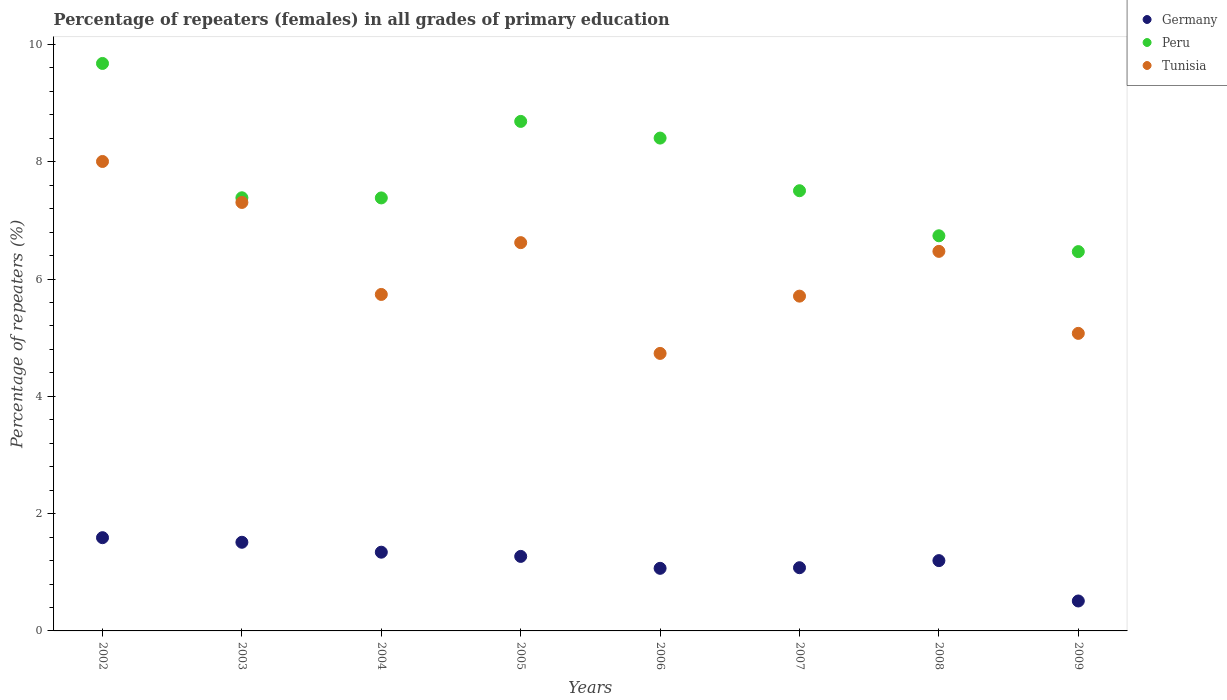What is the percentage of repeaters (females) in Germany in 2005?
Ensure brevity in your answer.  1.27. Across all years, what is the maximum percentage of repeaters (females) in Peru?
Make the answer very short. 9.68. Across all years, what is the minimum percentage of repeaters (females) in Peru?
Your answer should be very brief. 6.47. In which year was the percentage of repeaters (females) in Tunisia minimum?
Your answer should be very brief. 2006. What is the total percentage of repeaters (females) in Tunisia in the graph?
Offer a terse response. 49.65. What is the difference between the percentage of repeaters (females) in Germany in 2003 and that in 2008?
Keep it short and to the point. 0.31. What is the difference between the percentage of repeaters (females) in Tunisia in 2006 and the percentage of repeaters (females) in Peru in 2009?
Offer a very short reply. -1.74. What is the average percentage of repeaters (females) in Germany per year?
Provide a short and direct response. 1.2. In the year 2003, what is the difference between the percentage of repeaters (females) in Peru and percentage of repeaters (females) in Germany?
Your answer should be compact. 5.87. In how many years, is the percentage of repeaters (females) in Tunisia greater than 6.4 %?
Keep it short and to the point. 4. What is the ratio of the percentage of repeaters (females) in Tunisia in 2003 to that in 2008?
Give a very brief answer. 1.13. What is the difference between the highest and the second highest percentage of repeaters (females) in Germany?
Ensure brevity in your answer.  0.08. What is the difference between the highest and the lowest percentage of repeaters (females) in Peru?
Your response must be concise. 3.21. Is the sum of the percentage of repeaters (females) in Peru in 2002 and 2004 greater than the maximum percentage of repeaters (females) in Tunisia across all years?
Your response must be concise. Yes. Does the percentage of repeaters (females) in Peru monotonically increase over the years?
Your response must be concise. No. Is the percentage of repeaters (females) in Tunisia strictly greater than the percentage of repeaters (females) in Peru over the years?
Provide a short and direct response. No. Is the percentage of repeaters (females) in Tunisia strictly less than the percentage of repeaters (females) in Peru over the years?
Provide a short and direct response. Yes. How many years are there in the graph?
Give a very brief answer. 8. What is the difference between two consecutive major ticks on the Y-axis?
Give a very brief answer. 2. Are the values on the major ticks of Y-axis written in scientific E-notation?
Provide a succinct answer. No. Does the graph contain any zero values?
Your answer should be very brief. No. Does the graph contain grids?
Your answer should be very brief. No. Where does the legend appear in the graph?
Your response must be concise. Top right. How are the legend labels stacked?
Your response must be concise. Vertical. What is the title of the graph?
Provide a short and direct response. Percentage of repeaters (females) in all grades of primary education. Does "Andorra" appear as one of the legend labels in the graph?
Provide a succinct answer. No. What is the label or title of the Y-axis?
Provide a short and direct response. Percentage of repeaters (%). What is the Percentage of repeaters (%) in Germany in 2002?
Provide a short and direct response. 1.59. What is the Percentage of repeaters (%) of Peru in 2002?
Provide a short and direct response. 9.68. What is the Percentage of repeaters (%) in Tunisia in 2002?
Provide a succinct answer. 8. What is the Percentage of repeaters (%) in Germany in 2003?
Your response must be concise. 1.51. What is the Percentage of repeaters (%) in Peru in 2003?
Your response must be concise. 7.39. What is the Percentage of repeaters (%) of Tunisia in 2003?
Provide a short and direct response. 7.31. What is the Percentage of repeaters (%) in Germany in 2004?
Ensure brevity in your answer.  1.34. What is the Percentage of repeaters (%) of Peru in 2004?
Provide a short and direct response. 7.38. What is the Percentage of repeaters (%) of Tunisia in 2004?
Keep it short and to the point. 5.74. What is the Percentage of repeaters (%) of Germany in 2005?
Give a very brief answer. 1.27. What is the Percentage of repeaters (%) in Peru in 2005?
Provide a short and direct response. 8.69. What is the Percentage of repeaters (%) in Tunisia in 2005?
Your response must be concise. 6.62. What is the Percentage of repeaters (%) of Germany in 2006?
Provide a short and direct response. 1.07. What is the Percentage of repeaters (%) of Peru in 2006?
Offer a very short reply. 8.4. What is the Percentage of repeaters (%) in Tunisia in 2006?
Offer a terse response. 4.73. What is the Percentage of repeaters (%) of Germany in 2007?
Keep it short and to the point. 1.08. What is the Percentage of repeaters (%) in Peru in 2007?
Offer a very short reply. 7.51. What is the Percentage of repeaters (%) in Tunisia in 2007?
Keep it short and to the point. 5.71. What is the Percentage of repeaters (%) in Germany in 2008?
Offer a very short reply. 1.2. What is the Percentage of repeaters (%) of Peru in 2008?
Your answer should be very brief. 6.74. What is the Percentage of repeaters (%) in Tunisia in 2008?
Your answer should be compact. 6.47. What is the Percentage of repeaters (%) of Germany in 2009?
Provide a succinct answer. 0.51. What is the Percentage of repeaters (%) in Peru in 2009?
Keep it short and to the point. 6.47. What is the Percentage of repeaters (%) in Tunisia in 2009?
Make the answer very short. 5.07. Across all years, what is the maximum Percentage of repeaters (%) of Germany?
Your answer should be very brief. 1.59. Across all years, what is the maximum Percentage of repeaters (%) in Peru?
Ensure brevity in your answer.  9.68. Across all years, what is the maximum Percentage of repeaters (%) of Tunisia?
Provide a short and direct response. 8. Across all years, what is the minimum Percentage of repeaters (%) in Germany?
Your response must be concise. 0.51. Across all years, what is the minimum Percentage of repeaters (%) in Peru?
Keep it short and to the point. 6.47. Across all years, what is the minimum Percentage of repeaters (%) in Tunisia?
Offer a very short reply. 4.73. What is the total Percentage of repeaters (%) in Germany in the graph?
Offer a very short reply. 9.57. What is the total Percentage of repeaters (%) in Peru in the graph?
Give a very brief answer. 62.25. What is the total Percentage of repeaters (%) of Tunisia in the graph?
Offer a very short reply. 49.65. What is the difference between the Percentage of repeaters (%) of Germany in 2002 and that in 2003?
Offer a very short reply. 0.08. What is the difference between the Percentage of repeaters (%) in Peru in 2002 and that in 2003?
Your answer should be compact. 2.29. What is the difference between the Percentage of repeaters (%) of Tunisia in 2002 and that in 2003?
Your answer should be compact. 0.7. What is the difference between the Percentage of repeaters (%) in Germany in 2002 and that in 2004?
Offer a very short reply. 0.25. What is the difference between the Percentage of repeaters (%) of Peru in 2002 and that in 2004?
Give a very brief answer. 2.29. What is the difference between the Percentage of repeaters (%) in Tunisia in 2002 and that in 2004?
Provide a short and direct response. 2.27. What is the difference between the Percentage of repeaters (%) of Germany in 2002 and that in 2005?
Provide a short and direct response. 0.32. What is the difference between the Percentage of repeaters (%) in Tunisia in 2002 and that in 2005?
Provide a succinct answer. 1.38. What is the difference between the Percentage of repeaters (%) in Germany in 2002 and that in 2006?
Keep it short and to the point. 0.52. What is the difference between the Percentage of repeaters (%) in Peru in 2002 and that in 2006?
Offer a very short reply. 1.27. What is the difference between the Percentage of repeaters (%) in Tunisia in 2002 and that in 2006?
Offer a terse response. 3.27. What is the difference between the Percentage of repeaters (%) in Germany in 2002 and that in 2007?
Ensure brevity in your answer.  0.51. What is the difference between the Percentage of repeaters (%) in Peru in 2002 and that in 2007?
Offer a terse response. 2.17. What is the difference between the Percentage of repeaters (%) of Tunisia in 2002 and that in 2007?
Provide a succinct answer. 2.3. What is the difference between the Percentage of repeaters (%) in Germany in 2002 and that in 2008?
Offer a terse response. 0.39. What is the difference between the Percentage of repeaters (%) of Peru in 2002 and that in 2008?
Give a very brief answer. 2.94. What is the difference between the Percentage of repeaters (%) of Tunisia in 2002 and that in 2008?
Your answer should be compact. 1.53. What is the difference between the Percentage of repeaters (%) of Germany in 2002 and that in 2009?
Your response must be concise. 1.08. What is the difference between the Percentage of repeaters (%) of Peru in 2002 and that in 2009?
Provide a succinct answer. 3.21. What is the difference between the Percentage of repeaters (%) of Tunisia in 2002 and that in 2009?
Your answer should be very brief. 2.93. What is the difference between the Percentage of repeaters (%) of Germany in 2003 and that in 2004?
Provide a succinct answer. 0.17. What is the difference between the Percentage of repeaters (%) of Peru in 2003 and that in 2004?
Your answer should be very brief. 0. What is the difference between the Percentage of repeaters (%) in Tunisia in 2003 and that in 2004?
Your answer should be very brief. 1.57. What is the difference between the Percentage of repeaters (%) of Germany in 2003 and that in 2005?
Provide a succinct answer. 0.24. What is the difference between the Percentage of repeaters (%) in Peru in 2003 and that in 2005?
Your response must be concise. -1.3. What is the difference between the Percentage of repeaters (%) of Tunisia in 2003 and that in 2005?
Your answer should be compact. 0.69. What is the difference between the Percentage of repeaters (%) in Germany in 2003 and that in 2006?
Make the answer very short. 0.44. What is the difference between the Percentage of repeaters (%) of Peru in 2003 and that in 2006?
Your answer should be compact. -1.02. What is the difference between the Percentage of repeaters (%) in Tunisia in 2003 and that in 2006?
Ensure brevity in your answer.  2.57. What is the difference between the Percentage of repeaters (%) in Germany in 2003 and that in 2007?
Offer a very short reply. 0.43. What is the difference between the Percentage of repeaters (%) in Peru in 2003 and that in 2007?
Provide a short and direct response. -0.12. What is the difference between the Percentage of repeaters (%) of Tunisia in 2003 and that in 2007?
Offer a very short reply. 1.6. What is the difference between the Percentage of repeaters (%) in Germany in 2003 and that in 2008?
Your response must be concise. 0.31. What is the difference between the Percentage of repeaters (%) of Peru in 2003 and that in 2008?
Provide a short and direct response. 0.65. What is the difference between the Percentage of repeaters (%) of Tunisia in 2003 and that in 2008?
Ensure brevity in your answer.  0.83. What is the difference between the Percentage of repeaters (%) of Peru in 2003 and that in 2009?
Provide a short and direct response. 0.92. What is the difference between the Percentage of repeaters (%) of Tunisia in 2003 and that in 2009?
Your response must be concise. 2.23. What is the difference between the Percentage of repeaters (%) of Germany in 2004 and that in 2005?
Your answer should be compact. 0.07. What is the difference between the Percentage of repeaters (%) of Peru in 2004 and that in 2005?
Your response must be concise. -1.3. What is the difference between the Percentage of repeaters (%) of Tunisia in 2004 and that in 2005?
Your answer should be very brief. -0.88. What is the difference between the Percentage of repeaters (%) in Germany in 2004 and that in 2006?
Your answer should be compact. 0.28. What is the difference between the Percentage of repeaters (%) of Peru in 2004 and that in 2006?
Provide a short and direct response. -1.02. What is the difference between the Percentage of repeaters (%) in Germany in 2004 and that in 2007?
Ensure brevity in your answer.  0.26. What is the difference between the Percentage of repeaters (%) in Peru in 2004 and that in 2007?
Offer a very short reply. -0.12. What is the difference between the Percentage of repeaters (%) in Tunisia in 2004 and that in 2007?
Offer a very short reply. 0.03. What is the difference between the Percentage of repeaters (%) of Germany in 2004 and that in 2008?
Your response must be concise. 0.14. What is the difference between the Percentage of repeaters (%) in Peru in 2004 and that in 2008?
Offer a terse response. 0.65. What is the difference between the Percentage of repeaters (%) in Tunisia in 2004 and that in 2008?
Offer a very short reply. -0.73. What is the difference between the Percentage of repeaters (%) in Germany in 2004 and that in 2009?
Make the answer very short. 0.83. What is the difference between the Percentage of repeaters (%) in Peru in 2004 and that in 2009?
Provide a short and direct response. 0.92. What is the difference between the Percentage of repeaters (%) of Tunisia in 2004 and that in 2009?
Keep it short and to the point. 0.66. What is the difference between the Percentage of repeaters (%) of Germany in 2005 and that in 2006?
Provide a succinct answer. 0.2. What is the difference between the Percentage of repeaters (%) of Peru in 2005 and that in 2006?
Your answer should be very brief. 0.28. What is the difference between the Percentage of repeaters (%) of Tunisia in 2005 and that in 2006?
Provide a short and direct response. 1.89. What is the difference between the Percentage of repeaters (%) of Germany in 2005 and that in 2007?
Make the answer very short. 0.19. What is the difference between the Percentage of repeaters (%) of Peru in 2005 and that in 2007?
Provide a succinct answer. 1.18. What is the difference between the Percentage of repeaters (%) in Tunisia in 2005 and that in 2007?
Offer a very short reply. 0.91. What is the difference between the Percentage of repeaters (%) in Germany in 2005 and that in 2008?
Ensure brevity in your answer.  0.07. What is the difference between the Percentage of repeaters (%) in Peru in 2005 and that in 2008?
Offer a very short reply. 1.95. What is the difference between the Percentage of repeaters (%) of Tunisia in 2005 and that in 2008?
Your answer should be compact. 0.15. What is the difference between the Percentage of repeaters (%) of Germany in 2005 and that in 2009?
Your response must be concise. 0.76. What is the difference between the Percentage of repeaters (%) of Peru in 2005 and that in 2009?
Provide a succinct answer. 2.22. What is the difference between the Percentage of repeaters (%) in Tunisia in 2005 and that in 2009?
Make the answer very short. 1.55. What is the difference between the Percentage of repeaters (%) of Germany in 2006 and that in 2007?
Make the answer very short. -0.01. What is the difference between the Percentage of repeaters (%) of Peru in 2006 and that in 2007?
Provide a succinct answer. 0.9. What is the difference between the Percentage of repeaters (%) of Tunisia in 2006 and that in 2007?
Offer a very short reply. -0.98. What is the difference between the Percentage of repeaters (%) of Germany in 2006 and that in 2008?
Keep it short and to the point. -0.13. What is the difference between the Percentage of repeaters (%) in Peru in 2006 and that in 2008?
Give a very brief answer. 1.67. What is the difference between the Percentage of repeaters (%) in Tunisia in 2006 and that in 2008?
Make the answer very short. -1.74. What is the difference between the Percentage of repeaters (%) in Germany in 2006 and that in 2009?
Your answer should be very brief. 0.56. What is the difference between the Percentage of repeaters (%) of Peru in 2006 and that in 2009?
Provide a short and direct response. 1.94. What is the difference between the Percentage of repeaters (%) in Tunisia in 2006 and that in 2009?
Offer a very short reply. -0.34. What is the difference between the Percentage of repeaters (%) of Germany in 2007 and that in 2008?
Offer a terse response. -0.12. What is the difference between the Percentage of repeaters (%) in Peru in 2007 and that in 2008?
Give a very brief answer. 0.77. What is the difference between the Percentage of repeaters (%) in Tunisia in 2007 and that in 2008?
Your response must be concise. -0.76. What is the difference between the Percentage of repeaters (%) in Germany in 2007 and that in 2009?
Your answer should be compact. 0.57. What is the difference between the Percentage of repeaters (%) in Peru in 2007 and that in 2009?
Offer a very short reply. 1.04. What is the difference between the Percentage of repeaters (%) in Tunisia in 2007 and that in 2009?
Provide a succinct answer. 0.63. What is the difference between the Percentage of repeaters (%) in Germany in 2008 and that in 2009?
Provide a succinct answer. 0.69. What is the difference between the Percentage of repeaters (%) in Peru in 2008 and that in 2009?
Offer a terse response. 0.27. What is the difference between the Percentage of repeaters (%) of Tunisia in 2008 and that in 2009?
Give a very brief answer. 1.4. What is the difference between the Percentage of repeaters (%) in Germany in 2002 and the Percentage of repeaters (%) in Peru in 2003?
Provide a succinct answer. -5.8. What is the difference between the Percentage of repeaters (%) in Germany in 2002 and the Percentage of repeaters (%) in Tunisia in 2003?
Offer a terse response. -5.72. What is the difference between the Percentage of repeaters (%) in Peru in 2002 and the Percentage of repeaters (%) in Tunisia in 2003?
Provide a short and direct response. 2.37. What is the difference between the Percentage of repeaters (%) of Germany in 2002 and the Percentage of repeaters (%) of Peru in 2004?
Give a very brief answer. -5.79. What is the difference between the Percentage of repeaters (%) in Germany in 2002 and the Percentage of repeaters (%) in Tunisia in 2004?
Your answer should be compact. -4.15. What is the difference between the Percentage of repeaters (%) of Peru in 2002 and the Percentage of repeaters (%) of Tunisia in 2004?
Your answer should be compact. 3.94. What is the difference between the Percentage of repeaters (%) in Germany in 2002 and the Percentage of repeaters (%) in Peru in 2005?
Ensure brevity in your answer.  -7.1. What is the difference between the Percentage of repeaters (%) of Germany in 2002 and the Percentage of repeaters (%) of Tunisia in 2005?
Ensure brevity in your answer.  -5.03. What is the difference between the Percentage of repeaters (%) of Peru in 2002 and the Percentage of repeaters (%) of Tunisia in 2005?
Ensure brevity in your answer.  3.06. What is the difference between the Percentage of repeaters (%) of Germany in 2002 and the Percentage of repeaters (%) of Peru in 2006?
Offer a very short reply. -6.81. What is the difference between the Percentage of repeaters (%) in Germany in 2002 and the Percentage of repeaters (%) in Tunisia in 2006?
Your answer should be very brief. -3.14. What is the difference between the Percentage of repeaters (%) in Peru in 2002 and the Percentage of repeaters (%) in Tunisia in 2006?
Your answer should be compact. 4.94. What is the difference between the Percentage of repeaters (%) in Germany in 2002 and the Percentage of repeaters (%) in Peru in 2007?
Offer a very short reply. -5.92. What is the difference between the Percentage of repeaters (%) in Germany in 2002 and the Percentage of repeaters (%) in Tunisia in 2007?
Your response must be concise. -4.12. What is the difference between the Percentage of repeaters (%) in Peru in 2002 and the Percentage of repeaters (%) in Tunisia in 2007?
Your response must be concise. 3.97. What is the difference between the Percentage of repeaters (%) of Germany in 2002 and the Percentage of repeaters (%) of Peru in 2008?
Provide a short and direct response. -5.15. What is the difference between the Percentage of repeaters (%) of Germany in 2002 and the Percentage of repeaters (%) of Tunisia in 2008?
Provide a short and direct response. -4.88. What is the difference between the Percentage of repeaters (%) of Peru in 2002 and the Percentage of repeaters (%) of Tunisia in 2008?
Your response must be concise. 3.2. What is the difference between the Percentage of repeaters (%) of Germany in 2002 and the Percentage of repeaters (%) of Peru in 2009?
Offer a very short reply. -4.88. What is the difference between the Percentage of repeaters (%) in Germany in 2002 and the Percentage of repeaters (%) in Tunisia in 2009?
Offer a terse response. -3.48. What is the difference between the Percentage of repeaters (%) of Peru in 2002 and the Percentage of repeaters (%) of Tunisia in 2009?
Keep it short and to the point. 4.6. What is the difference between the Percentage of repeaters (%) of Germany in 2003 and the Percentage of repeaters (%) of Peru in 2004?
Provide a short and direct response. -5.87. What is the difference between the Percentage of repeaters (%) of Germany in 2003 and the Percentage of repeaters (%) of Tunisia in 2004?
Provide a short and direct response. -4.23. What is the difference between the Percentage of repeaters (%) of Peru in 2003 and the Percentage of repeaters (%) of Tunisia in 2004?
Ensure brevity in your answer.  1.65. What is the difference between the Percentage of repeaters (%) in Germany in 2003 and the Percentage of repeaters (%) in Peru in 2005?
Provide a short and direct response. -7.18. What is the difference between the Percentage of repeaters (%) in Germany in 2003 and the Percentage of repeaters (%) in Tunisia in 2005?
Keep it short and to the point. -5.11. What is the difference between the Percentage of repeaters (%) in Peru in 2003 and the Percentage of repeaters (%) in Tunisia in 2005?
Offer a very short reply. 0.76. What is the difference between the Percentage of repeaters (%) of Germany in 2003 and the Percentage of repeaters (%) of Peru in 2006?
Keep it short and to the point. -6.89. What is the difference between the Percentage of repeaters (%) in Germany in 2003 and the Percentage of repeaters (%) in Tunisia in 2006?
Offer a very short reply. -3.22. What is the difference between the Percentage of repeaters (%) of Peru in 2003 and the Percentage of repeaters (%) of Tunisia in 2006?
Make the answer very short. 2.65. What is the difference between the Percentage of repeaters (%) of Germany in 2003 and the Percentage of repeaters (%) of Peru in 2007?
Make the answer very short. -5.99. What is the difference between the Percentage of repeaters (%) of Germany in 2003 and the Percentage of repeaters (%) of Tunisia in 2007?
Keep it short and to the point. -4.2. What is the difference between the Percentage of repeaters (%) of Peru in 2003 and the Percentage of repeaters (%) of Tunisia in 2007?
Offer a terse response. 1.68. What is the difference between the Percentage of repeaters (%) in Germany in 2003 and the Percentage of repeaters (%) in Peru in 2008?
Provide a succinct answer. -5.23. What is the difference between the Percentage of repeaters (%) in Germany in 2003 and the Percentage of repeaters (%) in Tunisia in 2008?
Your answer should be very brief. -4.96. What is the difference between the Percentage of repeaters (%) in Peru in 2003 and the Percentage of repeaters (%) in Tunisia in 2008?
Provide a short and direct response. 0.91. What is the difference between the Percentage of repeaters (%) of Germany in 2003 and the Percentage of repeaters (%) of Peru in 2009?
Provide a short and direct response. -4.96. What is the difference between the Percentage of repeaters (%) in Germany in 2003 and the Percentage of repeaters (%) in Tunisia in 2009?
Ensure brevity in your answer.  -3.56. What is the difference between the Percentage of repeaters (%) of Peru in 2003 and the Percentage of repeaters (%) of Tunisia in 2009?
Your answer should be compact. 2.31. What is the difference between the Percentage of repeaters (%) in Germany in 2004 and the Percentage of repeaters (%) in Peru in 2005?
Keep it short and to the point. -7.35. What is the difference between the Percentage of repeaters (%) of Germany in 2004 and the Percentage of repeaters (%) of Tunisia in 2005?
Offer a very short reply. -5.28. What is the difference between the Percentage of repeaters (%) of Peru in 2004 and the Percentage of repeaters (%) of Tunisia in 2005?
Offer a terse response. 0.76. What is the difference between the Percentage of repeaters (%) in Germany in 2004 and the Percentage of repeaters (%) in Peru in 2006?
Offer a terse response. -7.06. What is the difference between the Percentage of repeaters (%) of Germany in 2004 and the Percentage of repeaters (%) of Tunisia in 2006?
Offer a terse response. -3.39. What is the difference between the Percentage of repeaters (%) of Peru in 2004 and the Percentage of repeaters (%) of Tunisia in 2006?
Keep it short and to the point. 2.65. What is the difference between the Percentage of repeaters (%) of Germany in 2004 and the Percentage of repeaters (%) of Peru in 2007?
Make the answer very short. -6.16. What is the difference between the Percentage of repeaters (%) in Germany in 2004 and the Percentage of repeaters (%) in Tunisia in 2007?
Provide a short and direct response. -4.37. What is the difference between the Percentage of repeaters (%) of Peru in 2004 and the Percentage of repeaters (%) of Tunisia in 2007?
Offer a terse response. 1.67. What is the difference between the Percentage of repeaters (%) of Germany in 2004 and the Percentage of repeaters (%) of Peru in 2008?
Your answer should be compact. -5.39. What is the difference between the Percentage of repeaters (%) in Germany in 2004 and the Percentage of repeaters (%) in Tunisia in 2008?
Provide a succinct answer. -5.13. What is the difference between the Percentage of repeaters (%) in Peru in 2004 and the Percentage of repeaters (%) in Tunisia in 2008?
Keep it short and to the point. 0.91. What is the difference between the Percentage of repeaters (%) of Germany in 2004 and the Percentage of repeaters (%) of Peru in 2009?
Your answer should be compact. -5.12. What is the difference between the Percentage of repeaters (%) of Germany in 2004 and the Percentage of repeaters (%) of Tunisia in 2009?
Make the answer very short. -3.73. What is the difference between the Percentage of repeaters (%) of Peru in 2004 and the Percentage of repeaters (%) of Tunisia in 2009?
Offer a very short reply. 2.31. What is the difference between the Percentage of repeaters (%) of Germany in 2005 and the Percentage of repeaters (%) of Peru in 2006?
Offer a terse response. -7.13. What is the difference between the Percentage of repeaters (%) in Germany in 2005 and the Percentage of repeaters (%) in Tunisia in 2006?
Your response must be concise. -3.46. What is the difference between the Percentage of repeaters (%) in Peru in 2005 and the Percentage of repeaters (%) in Tunisia in 2006?
Your answer should be compact. 3.96. What is the difference between the Percentage of repeaters (%) of Germany in 2005 and the Percentage of repeaters (%) of Peru in 2007?
Provide a succinct answer. -6.24. What is the difference between the Percentage of repeaters (%) in Germany in 2005 and the Percentage of repeaters (%) in Tunisia in 2007?
Offer a terse response. -4.44. What is the difference between the Percentage of repeaters (%) in Peru in 2005 and the Percentage of repeaters (%) in Tunisia in 2007?
Your response must be concise. 2.98. What is the difference between the Percentage of repeaters (%) of Germany in 2005 and the Percentage of repeaters (%) of Peru in 2008?
Your answer should be very brief. -5.47. What is the difference between the Percentage of repeaters (%) of Germany in 2005 and the Percentage of repeaters (%) of Tunisia in 2008?
Provide a succinct answer. -5.2. What is the difference between the Percentage of repeaters (%) in Peru in 2005 and the Percentage of repeaters (%) in Tunisia in 2008?
Keep it short and to the point. 2.22. What is the difference between the Percentage of repeaters (%) of Germany in 2005 and the Percentage of repeaters (%) of Peru in 2009?
Ensure brevity in your answer.  -5.2. What is the difference between the Percentage of repeaters (%) in Germany in 2005 and the Percentage of repeaters (%) in Tunisia in 2009?
Give a very brief answer. -3.8. What is the difference between the Percentage of repeaters (%) in Peru in 2005 and the Percentage of repeaters (%) in Tunisia in 2009?
Give a very brief answer. 3.61. What is the difference between the Percentage of repeaters (%) of Germany in 2006 and the Percentage of repeaters (%) of Peru in 2007?
Give a very brief answer. -6.44. What is the difference between the Percentage of repeaters (%) of Germany in 2006 and the Percentage of repeaters (%) of Tunisia in 2007?
Make the answer very short. -4.64. What is the difference between the Percentage of repeaters (%) in Peru in 2006 and the Percentage of repeaters (%) in Tunisia in 2007?
Offer a very short reply. 2.69. What is the difference between the Percentage of repeaters (%) of Germany in 2006 and the Percentage of repeaters (%) of Peru in 2008?
Offer a very short reply. -5.67. What is the difference between the Percentage of repeaters (%) of Germany in 2006 and the Percentage of repeaters (%) of Tunisia in 2008?
Ensure brevity in your answer.  -5.4. What is the difference between the Percentage of repeaters (%) of Peru in 2006 and the Percentage of repeaters (%) of Tunisia in 2008?
Provide a short and direct response. 1.93. What is the difference between the Percentage of repeaters (%) in Germany in 2006 and the Percentage of repeaters (%) in Peru in 2009?
Provide a succinct answer. -5.4. What is the difference between the Percentage of repeaters (%) of Germany in 2006 and the Percentage of repeaters (%) of Tunisia in 2009?
Give a very brief answer. -4.01. What is the difference between the Percentage of repeaters (%) in Peru in 2006 and the Percentage of repeaters (%) in Tunisia in 2009?
Keep it short and to the point. 3.33. What is the difference between the Percentage of repeaters (%) in Germany in 2007 and the Percentage of repeaters (%) in Peru in 2008?
Offer a very short reply. -5.66. What is the difference between the Percentage of repeaters (%) of Germany in 2007 and the Percentage of repeaters (%) of Tunisia in 2008?
Your response must be concise. -5.39. What is the difference between the Percentage of repeaters (%) of Peru in 2007 and the Percentage of repeaters (%) of Tunisia in 2008?
Your answer should be compact. 1.03. What is the difference between the Percentage of repeaters (%) in Germany in 2007 and the Percentage of repeaters (%) in Peru in 2009?
Give a very brief answer. -5.39. What is the difference between the Percentage of repeaters (%) of Germany in 2007 and the Percentage of repeaters (%) of Tunisia in 2009?
Provide a short and direct response. -4. What is the difference between the Percentage of repeaters (%) in Peru in 2007 and the Percentage of repeaters (%) in Tunisia in 2009?
Keep it short and to the point. 2.43. What is the difference between the Percentage of repeaters (%) of Germany in 2008 and the Percentage of repeaters (%) of Peru in 2009?
Provide a short and direct response. -5.27. What is the difference between the Percentage of repeaters (%) in Germany in 2008 and the Percentage of repeaters (%) in Tunisia in 2009?
Provide a short and direct response. -3.87. What is the difference between the Percentage of repeaters (%) of Peru in 2008 and the Percentage of repeaters (%) of Tunisia in 2009?
Provide a short and direct response. 1.66. What is the average Percentage of repeaters (%) of Germany per year?
Your answer should be compact. 1.2. What is the average Percentage of repeaters (%) of Peru per year?
Provide a succinct answer. 7.78. What is the average Percentage of repeaters (%) of Tunisia per year?
Provide a short and direct response. 6.21. In the year 2002, what is the difference between the Percentage of repeaters (%) of Germany and Percentage of repeaters (%) of Peru?
Keep it short and to the point. -8.09. In the year 2002, what is the difference between the Percentage of repeaters (%) of Germany and Percentage of repeaters (%) of Tunisia?
Ensure brevity in your answer.  -6.41. In the year 2002, what is the difference between the Percentage of repeaters (%) of Peru and Percentage of repeaters (%) of Tunisia?
Offer a very short reply. 1.67. In the year 2003, what is the difference between the Percentage of repeaters (%) in Germany and Percentage of repeaters (%) in Peru?
Make the answer very short. -5.87. In the year 2003, what is the difference between the Percentage of repeaters (%) of Germany and Percentage of repeaters (%) of Tunisia?
Keep it short and to the point. -5.79. In the year 2003, what is the difference between the Percentage of repeaters (%) of Peru and Percentage of repeaters (%) of Tunisia?
Ensure brevity in your answer.  0.08. In the year 2004, what is the difference between the Percentage of repeaters (%) of Germany and Percentage of repeaters (%) of Peru?
Offer a very short reply. -6.04. In the year 2004, what is the difference between the Percentage of repeaters (%) of Germany and Percentage of repeaters (%) of Tunisia?
Your answer should be very brief. -4.39. In the year 2004, what is the difference between the Percentage of repeaters (%) of Peru and Percentage of repeaters (%) of Tunisia?
Provide a short and direct response. 1.65. In the year 2005, what is the difference between the Percentage of repeaters (%) of Germany and Percentage of repeaters (%) of Peru?
Make the answer very short. -7.42. In the year 2005, what is the difference between the Percentage of repeaters (%) in Germany and Percentage of repeaters (%) in Tunisia?
Your answer should be compact. -5.35. In the year 2005, what is the difference between the Percentage of repeaters (%) of Peru and Percentage of repeaters (%) of Tunisia?
Ensure brevity in your answer.  2.07. In the year 2006, what is the difference between the Percentage of repeaters (%) in Germany and Percentage of repeaters (%) in Peru?
Your response must be concise. -7.34. In the year 2006, what is the difference between the Percentage of repeaters (%) in Germany and Percentage of repeaters (%) in Tunisia?
Ensure brevity in your answer.  -3.66. In the year 2006, what is the difference between the Percentage of repeaters (%) in Peru and Percentage of repeaters (%) in Tunisia?
Keep it short and to the point. 3.67. In the year 2007, what is the difference between the Percentage of repeaters (%) in Germany and Percentage of repeaters (%) in Peru?
Your answer should be very brief. -6.43. In the year 2007, what is the difference between the Percentage of repeaters (%) in Germany and Percentage of repeaters (%) in Tunisia?
Your answer should be compact. -4.63. In the year 2007, what is the difference between the Percentage of repeaters (%) of Peru and Percentage of repeaters (%) of Tunisia?
Your response must be concise. 1.8. In the year 2008, what is the difference between the Percentage of repeaters (%) in Germany and Percentage of repeaters (%) in Peru?
Keep it short and to the point. -5.54. In the year 2008, what is the difference between the Percentage of repeaters (%) in Germany and Percentage of repeaters (%) in Tunisia?
Your response must be concise. -5.27. In the year 2008, what is the difference between the Percentage of repeaters (%) in Peru and Percentage of repeaters (%) in Tunisia?
Make the answer very short. 0.27. In the year 2009, what is the difference between the Percentage of repeaters (%) of Germany and Percentage of repeaters (%) of Peru?
Provide a short and direct response. -5.96. In the year 2009, what is the difference between the Percentage of repeaters (%) in Germany and Percentage of repeaters (%) in Tunisia?
Make the answer very short. -4.56. In the year 2009, what is the difference between the Percentage of repeaters (%) in Peru and Percentage of repeaters (%) in Tunisia?
Give a very brief answer. 1.39. What is the ratio of the Percentage of repeaters (%) of Germany in 2002 to that in 2003?
Your answer should be compact. 1.05. What is the ratio of the Percentage of repeaters (%) of Peru in 2002 to that in 2003?
Ensure brevity in your answer.  1.31. What is the ratio of the Percentage of repeaters (%) in Tunisia in 2002 to that in 2003?
Give a very brief answer. 1.1. What is the ratio of the Percentage of repeaters (%) in Germany in 2002 to that in 2004?
Offer a very short reply. 1.18. What is the ratio of the Percentage of repeaters (%) of Peru in 2002 to that in 2004?
Make the answer very short. 1.31. What is the ratio of the Percentage of repeaters (%) of Tunisia in 2002 to that in 2004?
Your answer should be compact. 1.4. What is the ratio of the Percentage of repeaters (%) of Germany in 2002 to that in 2005?
Your answer should be very brief. 1.25. What is the ratio of the Percentage of repeaters (%) in Peru in 2002 to that in 2005?
Offer a terse response. 1.11. What is the ratio of the Percentage of repeaters (%) of Tunisia in 2002 to that in 2005?
Your response must be concise. 1.21. What is the ratio of the Percentage of repeaters (%) in Germany in 2002 to that in 2006?
Your answer should be very brief. 1.49. What is the ratio of the Percentage of repeaters (%) of Peru in 2002 to that in 2006?
Keep it short and to the point. 1.15. What is the ratio of the Percentage of repeaters (%) of Tunisia in 2002 to that in 2006?
Give a very brief answer. 1.69. What is the ratio of the Percentage of repeaters (%) of Germany in 2002 to that in 2007?
Keep it short and to the point. 1.48. What is the ratio of the Percentage of repeaters (%) of Peru in 2002 to that in 2007?
Provide a short and direct response. 1.29. What is the ratio of the Percentage of repeaters (%) in Tunisia in 2002 to that in 2007?
Ensure brevity in your answer.  1.4. What is the ratio of the Percentage of repeaters (%) in Germany in 2002 to that in 2008?
Provide a succinct answer. 1.33. What is the ratio of the Percentage of repeaters (%) in Peru in 2002 to that in 2008?
Provide a short and direct response. 1.44. What is the ratio of the Percentage of repeaters (%) in Tunisia in 2002 to that in 2008?
Provide a short and direct response. 1.24. What is the ratio of the Percentage of repeaters (%) of Germany in 2002 to that in 2009?
Your answer should be very brief. 3.11. What is the ratio of the Percentage of repeaters (%) of Peru in 2002 to that in 2009?
Your answer should be compact. 1.5. What is the ratio of the Percentage of repeaters (%) in Tunisia in 2002 to that in 2009?
Your answer should be compact. 1.58. What is the ratio of the Percentage of repeaters (%) in Germany in 2003 to that in 2004?
Your answer should be compact. 1.13. What is the ratio of the Percentage of repeaters (%) in Peru in 2003 to that in 2004?
Offer a very short reply. 1. What is the ratio of the Percentage of repeaters (%) in Tunisia in 2003 to that in 2004?
Make the answer very short. 1.27. What is the ratio of the Percentage of repeaters (%) in Germany in 2003 to that in 2005?
Provide a short and direct response. 1.19. What is the ratio of the Percentage of repeaters (%) of Peru in 2003 to that in 2005?
Offer a very short reply. 0.85. What is the ratio of the Percentage of repeaters (%) in Tunisia in 2003 to that in 2005?
Your answer should be very brief. 1.1. What is the ratio of the Percentage of repeaters (%) in Germany in 2003 to that in 2006?
Offer a very short reply. 1.42. What is the ratio of the Percentage of repeaters (%) in Peru in 2003 to that in 2006?
Offer a terse response. 0.88. What is the ratio of the Percentage of repeaters (%) of Tunisia in 2003 to that in 2006?
Your answer should be very brief. 1.54. What is the ratio of the Percentage of repeaters (%) in Germany in 2003 to that in 2007?
Keep it short and to the point. 1.4. What is the ratio of the Percentage of repeaters (%) of Peru in 2003 to that in 2007?
Your answer should be very brief. 0.98. What is the ratio of the Percentage of repeaters (%) of Tunisia in 2003 to that in 2007?
Make the answer very short. 1.28. What is the ratio of the Percentage of repeaters (%) in Germany in 2003 to that in 2008?
Provide a succinct answer. 1.26. What is the ratio of the Percentage of repeaters (%) in Peru in 2003 to that in 2008?
Keep it short and to the point. 1.1. What is the ratio of the Percentage of repeaters (%) in Tunisia in 2003 to that in 2008?
Your response must be concise. 1.13. What is the ratio of the Percentage of repeaters (%) of Germany in 2003 to that in 2009?
Offer a terse response. 2.96. What is the ratio of the Percentage of repeaters (%) in Peru in 2003 to that in 2009?
Give a very brief answer. 1.14. What is the ratio of the Percentage of repeaters (%) in Tunisia in 2003 to that in 2009?
Make the answer very short. 1.44. What is the ratio of the Percentage of repeaters (%) in Germany in 2004 to that in 2005?
Ensure brevity in your answer.  1.06. What is the ratio of the Percentage of repeaters (%) of Peru in 2004 to that in 2005?
Provide a succinct answer. 0.85. What is the ratio of the Percentage of repeaters (%) of Tunisia in 2004 to that in 2005?
Provide a short and direct response. 0.87. What is the ratio of the Percentage of repeaters (%) in Germany in 2004 to that in 2006?
Keep it short and to the point. 1.26. What is the ratio of the Percentage of repeaters (%) of Peru in 2004 to that in 2006?
Ensure brevity in your answer.  0.88. What is the ratio of the Percentage of repeaters (%) of Tunisia in 2004 to that in 2006?
Offer a very short reply. 1.21. What is the ratio of the Percentage of repeaters (%) in Germany in 2004 to that in 2007?
Your answer should be compact. 1.25. What is the ratio of the Percentage of repeaters (%) of Peru in 2004 to that in 2007?
Your answer should be very brief. 0.98. What is the ratio of the Percentage of repeaters (%) in Germany in 2004 to that in 2008?
Offer a terse response. 1.12. What is the ratio of the Percentage of repeaters (%) in Peru in 2004 to that in 2008?
Your answer should be very brief. 1.1. What is the ratio of the Percentage of repeaters (%) in Tunisia in 2004 to that in 2008?
Make the answer very short. 0.89. What is the ratio of the Percentage of repeaters (%) of Germany in 2004 to that in 2009?
Make the answer very short. 2.63. What is the ratio of the Percentage of repeaters (%) in Peru in 2004 to that in 2009?
Offer a terse response. 1.14. What is the ratio of the Percentage of repeaters (%) of Tunisia in 2004 to that in 2009?
Ensure brevity in your answer.  1.13. What is the ratio of the Percentage of repeaters (%) in Germany in 2005 to that in 2006?
Your response must be concise. 1.19. What is the ratio of the Percentage of repeaters (%) in Peru in 2005 to that in 2006?
Your response must be concise. 1.03. What is the ratio of the Percentage of repeaters (%) in Tunisia in 2005 to that in 2006?
Ensure brevity in your answer.  1.4. What is the ratio of the Percentage of repeaters (%) of Germany in 2005 to that in 2007?
Provide a short and direct response. 1.18. What is the ratio of the Percentage of repeaters (%) of Peru in 2005 to that in 2007?
Keep it short and to the point. 1.16. What is the ratio of the Percentage of repeaters (%) in Tunisia in 2005 to that in 2007?
Offer a terse response. 1.16. What is the ratio of the Percentage of repeaters (%) in Germany in 2005 to that in 2008?
Offer a terse response. 1.06. What is the ratio of the Percentage of repeaters (%) in Peru in 2005 to that in 2008?
Keep it short and to the point. 1.29. What is the ratio of the Percentage of repeaters (%) in Tunisia in 2005 to that in 2008?
Provide a succinct answer. 1.02. What is the ratio of the Percentage of repeaters (%) in Germany in 2005 to that in 2009?
Your answer should be very brief. 2.49. What is the ratio of the Percentage of repeaters (%) in Peru in 2005 to that in 2009?
Give a very brief answer. 1.34. What is the ratio of the Percentage of repeaters (%) in Tunisia in 2005 to that in 2009?
Provide a short and direct response. 1.3. What is the ratio of the Percentage of repeaters (%) of Germany in 2006 to that in 2007?
Provide a succinct answer. 0.99. What is the ratio of the Percentage of repeaters (%) of Peru in 2006 to that in 2007?
Offer a very short reply. 1.12. What is the ratio of the Percentage of repeaters (%) in Tunisia in 2006 to that in 2007?
Provide a short and direct response. 0.83. What is the ratio of the Percentage of repeaters (%) of Germany in 2006 to that in 2008?
Keep it short and to the point. 0.89. What is the ratio of the Percentage of repeaters (%) of Peru in 2006 to that in 2008?
Keep it short and to the point. 1.25. What is the ratio of the Percentage of repeaters (%) in Tunisia in 2006 to that in 2008?
Offer a very short reply. 0.73. What is the ratio of the Percentage of repeaters (%) of Germany in 2006 to that in 2009?
Keep it short and to the point. 2.09. What is the ratio of the Percentage of repeaters (%) of Peru in 2006 to that in 2009?
Your response must be concise. 1.3. What is the ratio of the Percentage of repeaters (%) in Tunisia in 2006 to that in 2009?
Make the answer very short. 0.93. What is the ratio of the Percentage of repeaters (%) in Germany in 2007 to that in 2008?
Your answer should be very brief. 0.9. What is the ratio of the Percentage of repeaters (%) of Peru in 2007 to that in 2008?
Provide a succinct answer. 1.11. What is the ratio of the Percentage of repeaters (%) of Tunisia in 2007 to that in 2008?
Your response must be concise. 0.88. What is the ratio of the Percentage of repeaters (%) in Germany in 2007 to that in 2009?
Provide a succinct answer. 2.11. What is the ratio of the Percentage of repeaters (%) in Peru in 2007 to that in 2009?
Offer a very short reply. 1.16. What is the ratio of the Percentage of repeaters (%) of Tunisia in 2007 to that in 2009?
Offer a very short reply. 1.13. What is the ratio of the Percentage of repeaters (%) of Germany in 2008 to that in 2009?
Keep it short and to the point. 2.35. What is the ratio of the Percentage of repeaters (%) in Peru in 2008 to that in 2009?
Provide a short and direct response. 1.04. What is the ratio of the Percentage of repeaters (%) in Tunisia in 2008 to that in 2009?
Ensure brevity in your answer.  1.28. What is the difference between the highest and the second highest Percentage of repeaters (%) of Germany?
Keep it short and to the point. 0.08. What is the difference between the highest and the second highest Percentage of repeaters (%) in Tunisia?
Offer a terse response. 0.7. What is the difference between the highest and the lowest Percentage of repeaters (%) of Germany?
Offer a very short reply. 1.08. What is the difference between the highest and the lowest Percentage of repeaters (%) in Peru?
Give a very brief answer. 3.21. What is the difference between the highest and the lowest Percentage of repeaters (%) in Tunisia?
Offer a very short reply. 3.27. 